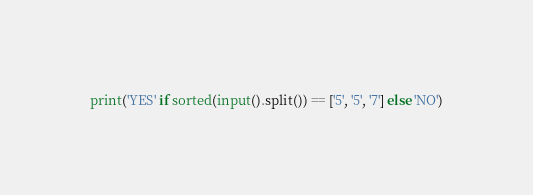<code> <loc_0><loc_0><loc_500><loc_500><_Python_>print('YES' if sorted(input().split()) == ['5', '5', '7'] else 'NO')</code> 